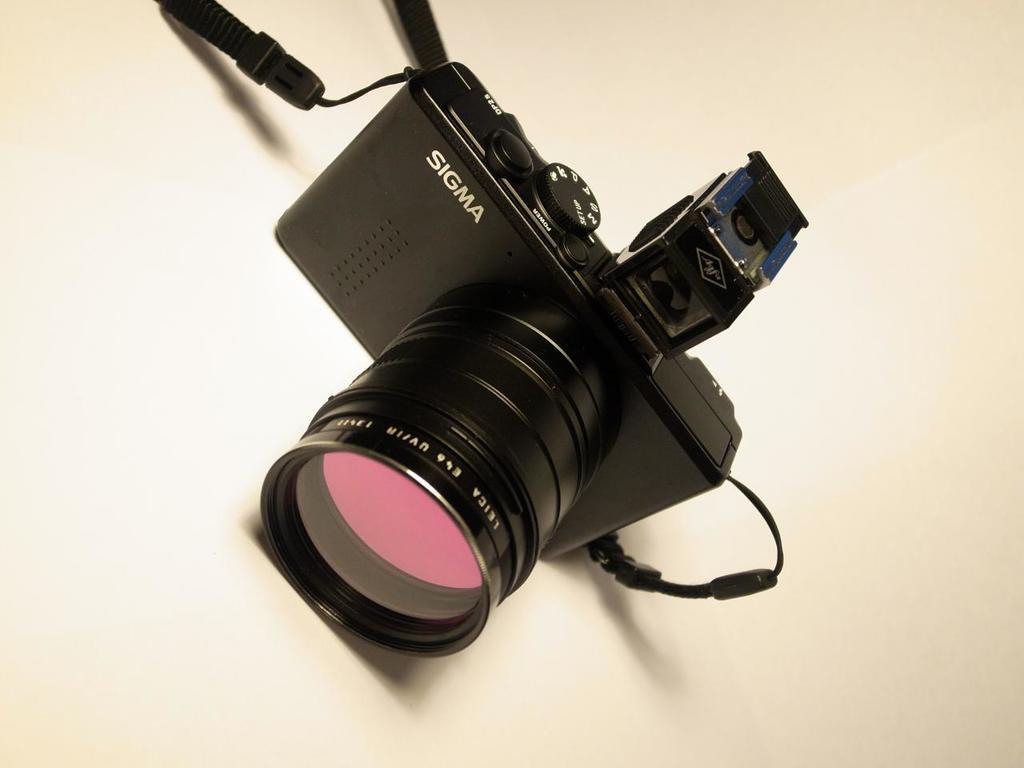What is the main object in the image? There is a camera in the image. Where is the camera located? The camera is on a platform. What type of meal is being prepared on the camera in the image? There is no meal being prepared on the camera in the image, as it is a camera and not a cooking appliance. 